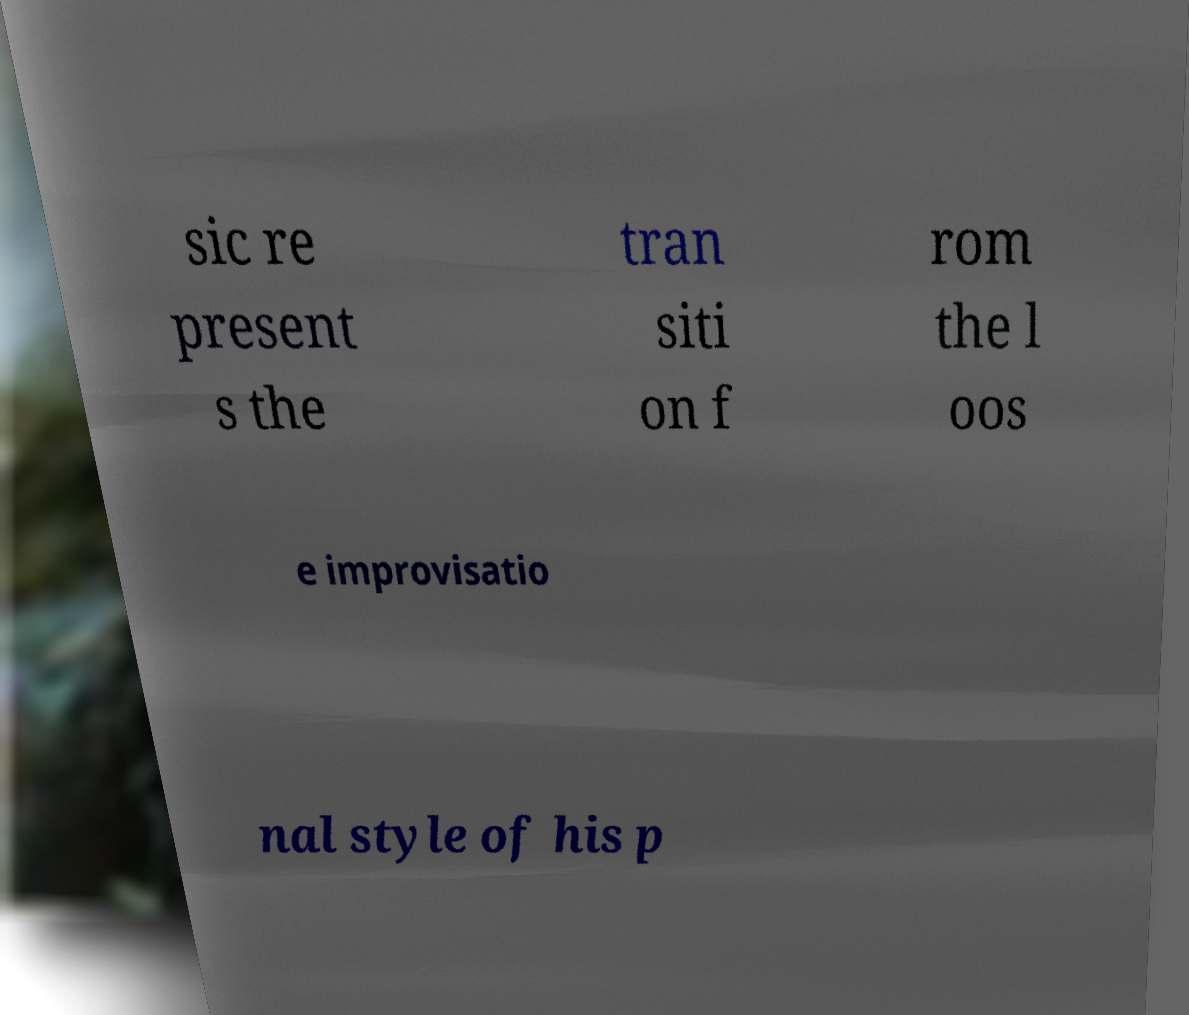What messages or text are displayed in this image? I need them in a readable, typed format. sic re present s the tran siti on f rom the l oos e improvisatio nal style of his p 